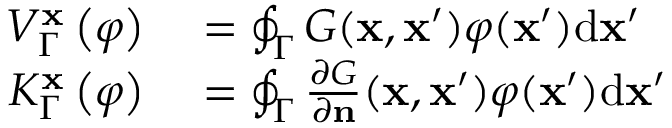Convert formula to latex. <formula><loc_0><loc_0><loc_500><loc_500>\begin{array} { r l } { V _ { \Gamma } ^ { x } \left ( \varphi \right ) } & = \oint _ { \Gamma } G ( x , x ^ { \prime } ) \varphi ( x ^ { \prime } ) { d } x ^ { \prime } } \\ { K _ { \Gamma } ^ { x } \left ( \varphi \right ) } & = \oint _ { \Gamma } \frac { \partial G } { \partial n } ( x , x ^ { \prime } ) \varphi ( x ^ { \prime } ) { d } x ^ { \prime } } \end{array}</formula> 